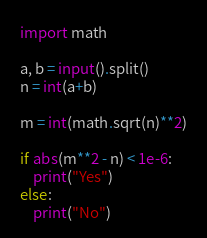<code> <loc_0><loc_0><loc_500><loc_500><_Python_>import math

a, b = input().split()
n = int(a+b)

m = int(math.sqrt(n)**2)

if abs(m**2 - n) < 1e-6:
    print("Yes")
else:
    print("No")</code> 